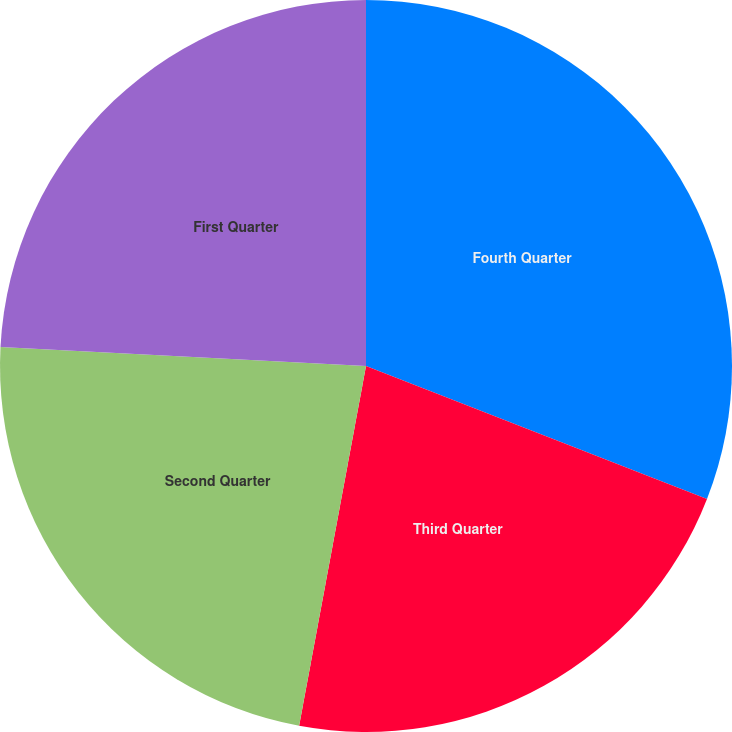Convert chart. <chart><loc_0><loc_0><loc_500><loc_500><pie_chart><fcel>Fourth Quarter<fcel>Third Quarter<fcel>Second Quarter<fcel>First Quarter<nl><fcel>30.92%<fcel>22.01%<fcel>22.9%<fcel>24.18%<nl></chart> 